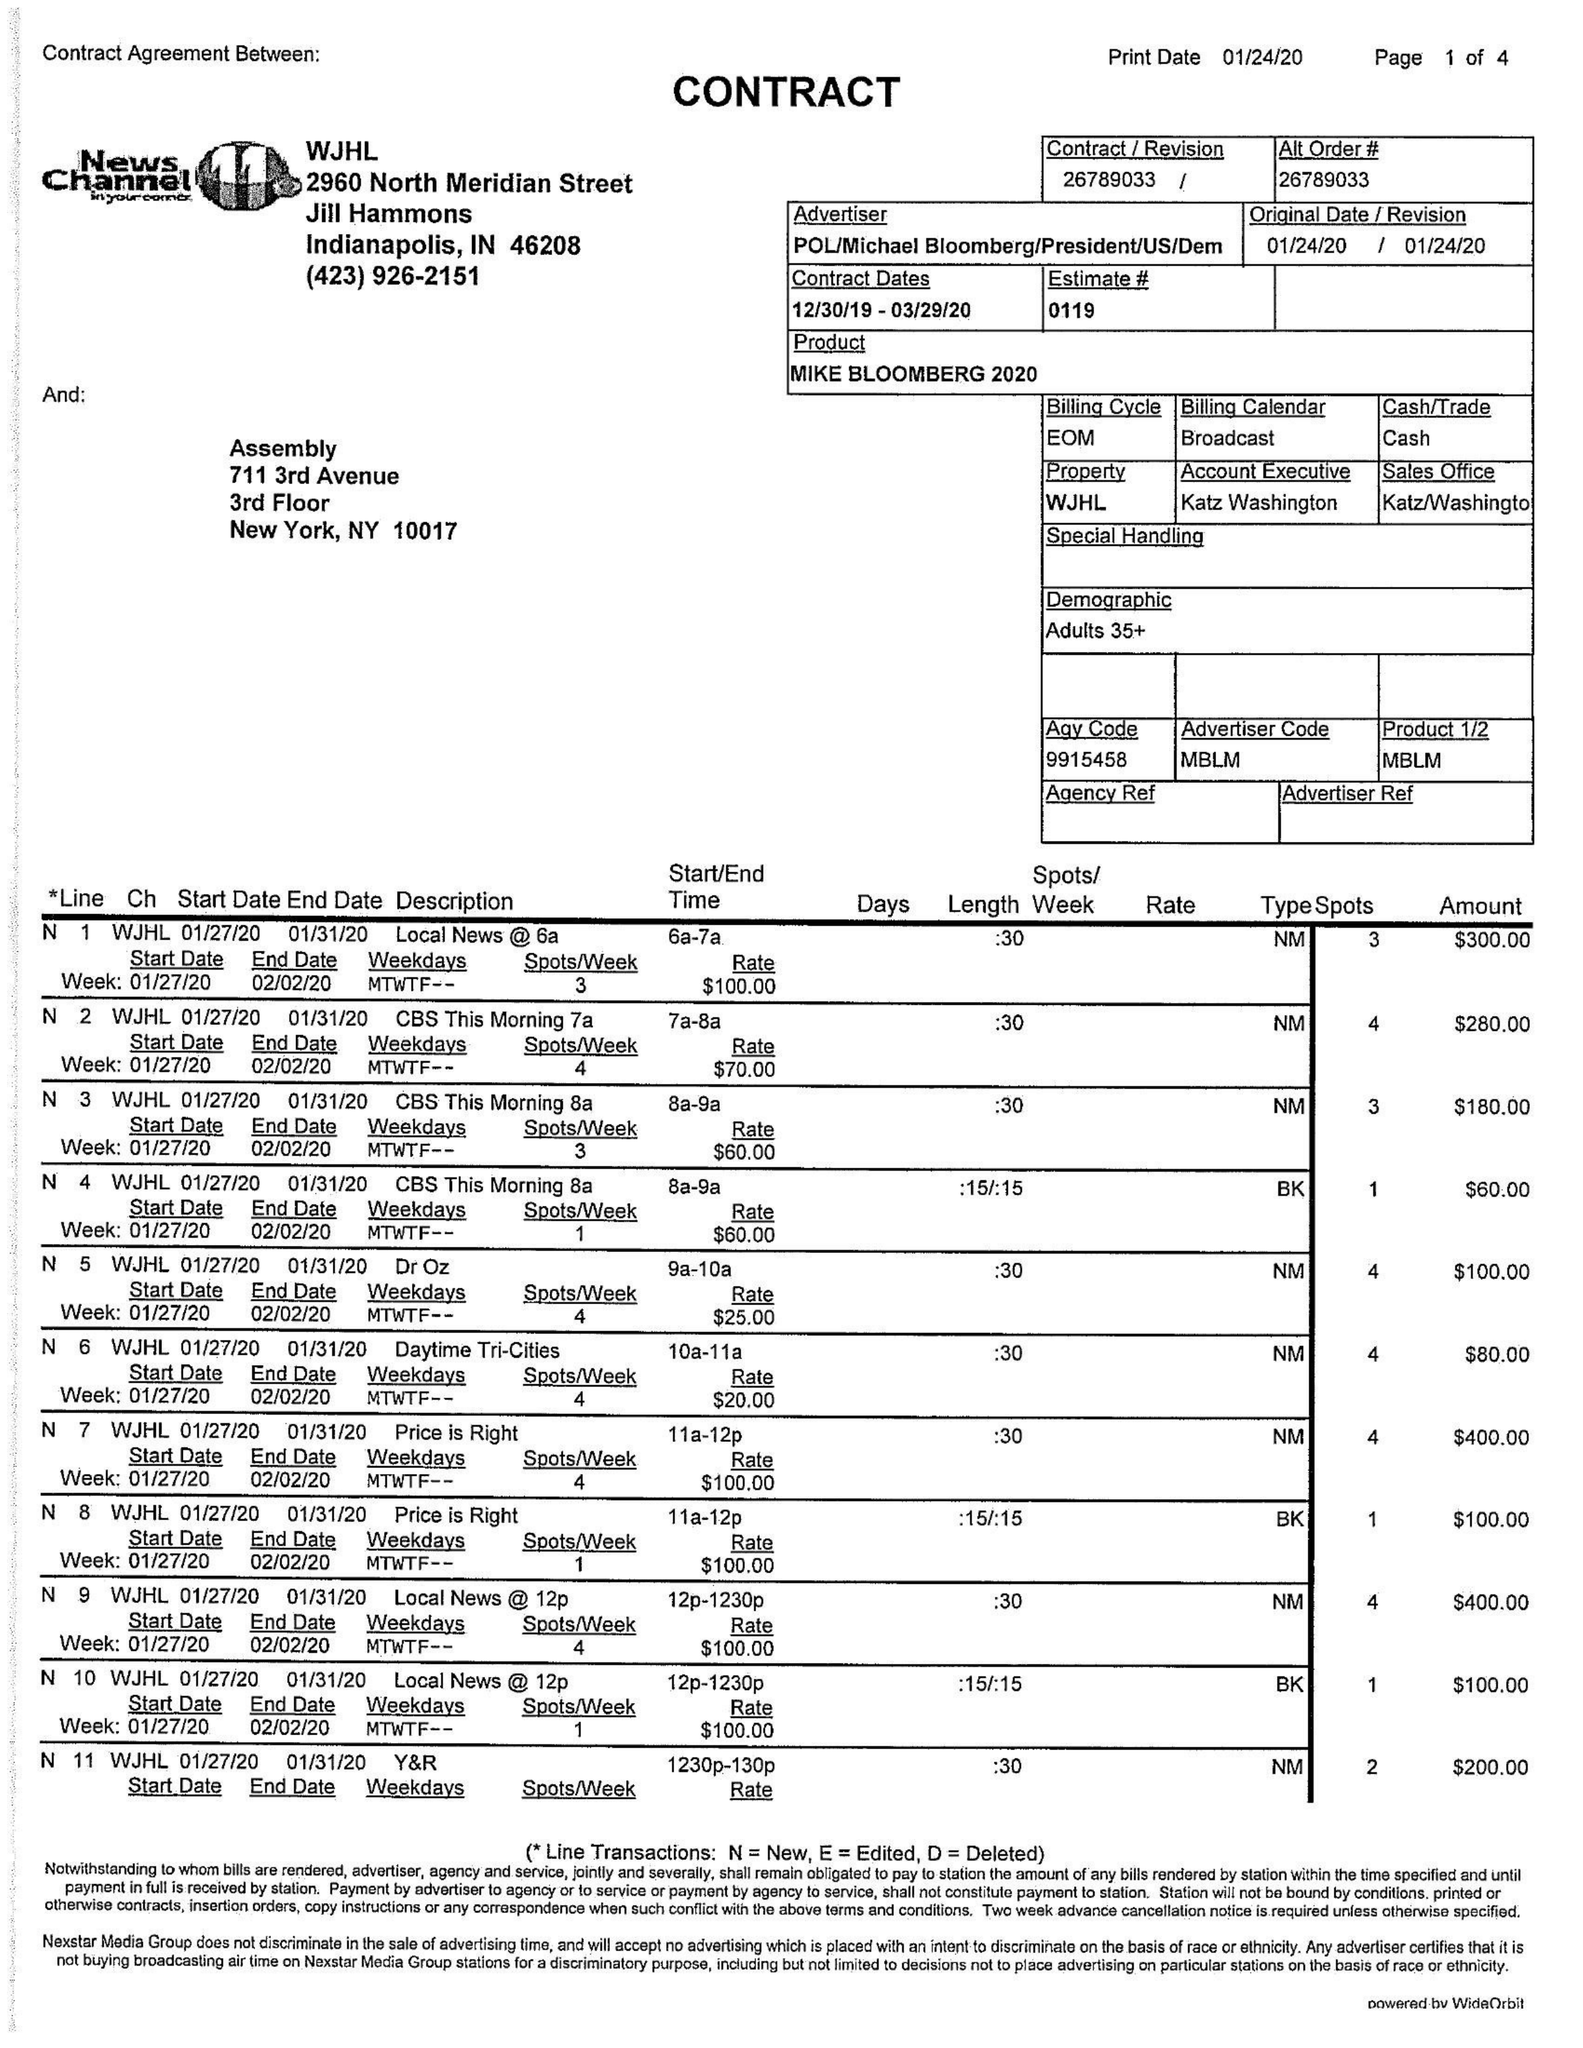What is the value for the gross_amount?
Answer the question using a single word or phrase. None 